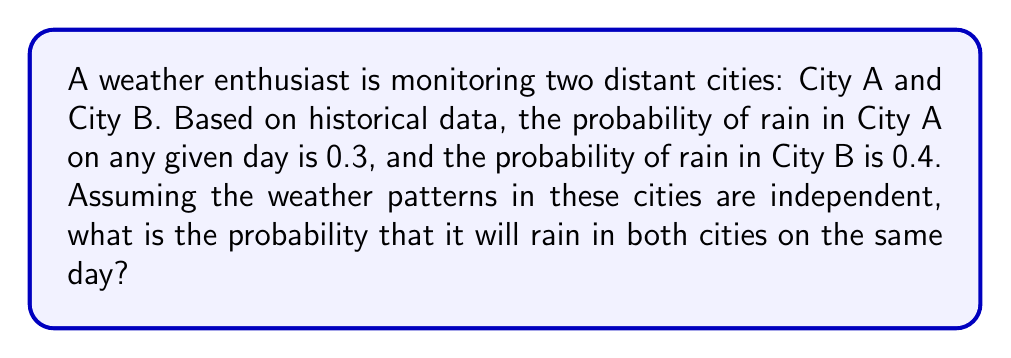Give your solution to this math problem. Let's approach this step-by-step:

1) Let's define our events:
   $R_A$ = Event that it rains in City A
   $R_B$ = Event that it rains in City B

2) We're given the following probabilities:
   $P(R_A) = 0.3$
   $P(R_B) = 0.4$

3) We need to find the probability of both events occurring simultaneously. In probability theory, this is called the joint probability.

4) Since we're told that the weather patterns in these cities are independent, we can use the multiplication rule for independent events:

   $P(R_A \text{ and } R_B) = P(R_A) \cdot P(R_B)$

5) Now, let's substitute the values:

   $P(R_A \text{ and } R_B) = 0.3 \cdot 0.4$

6) Calculate:
   $P(R_A \text{ and } R_B) = 0.12$

Therefore, the probability that it will rain in both cities on the same day is 0.12 or 12%.
Answer: 0.12 